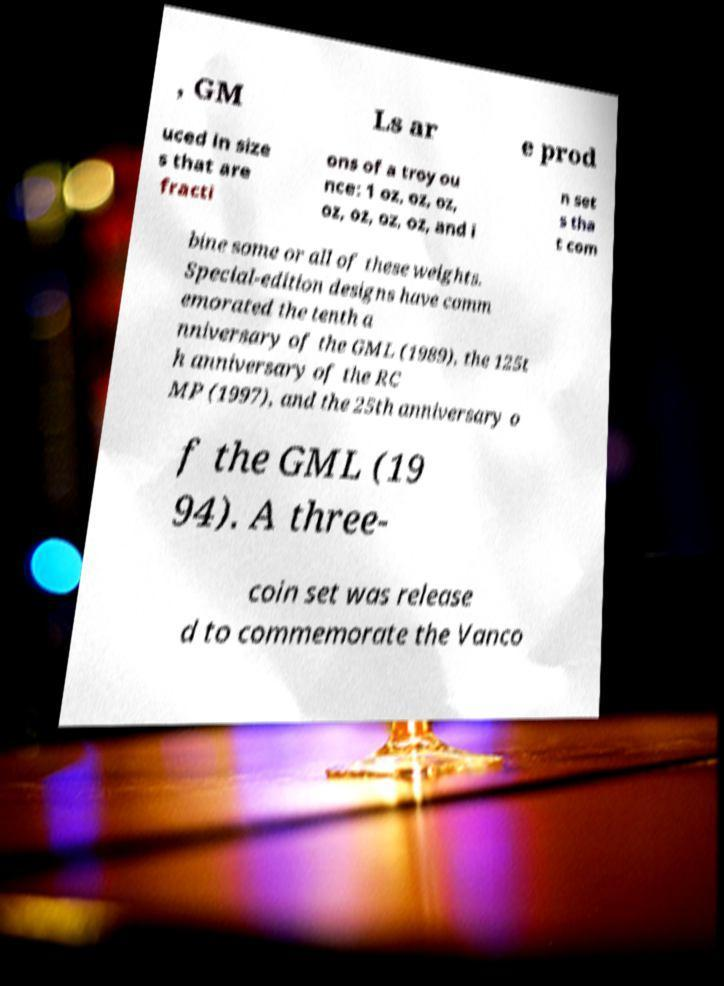Please read and relay the text visible in this image. What does it say? , GM Ls ar e prod uced in size s that are fracti ons of a troy ou nce: 1 oz, oz, oz, oz, oz, oz, oz, and i n set s tha t com bine some or all of these weights. Special-edition designs have comm emorated the tenth a nniversary of the GML (1989), the 125t h anniversary of the RC MP (1997), and the 25th anniversary o f the GML (19 94). A three- coin set was release d to commemorate the Vanco 